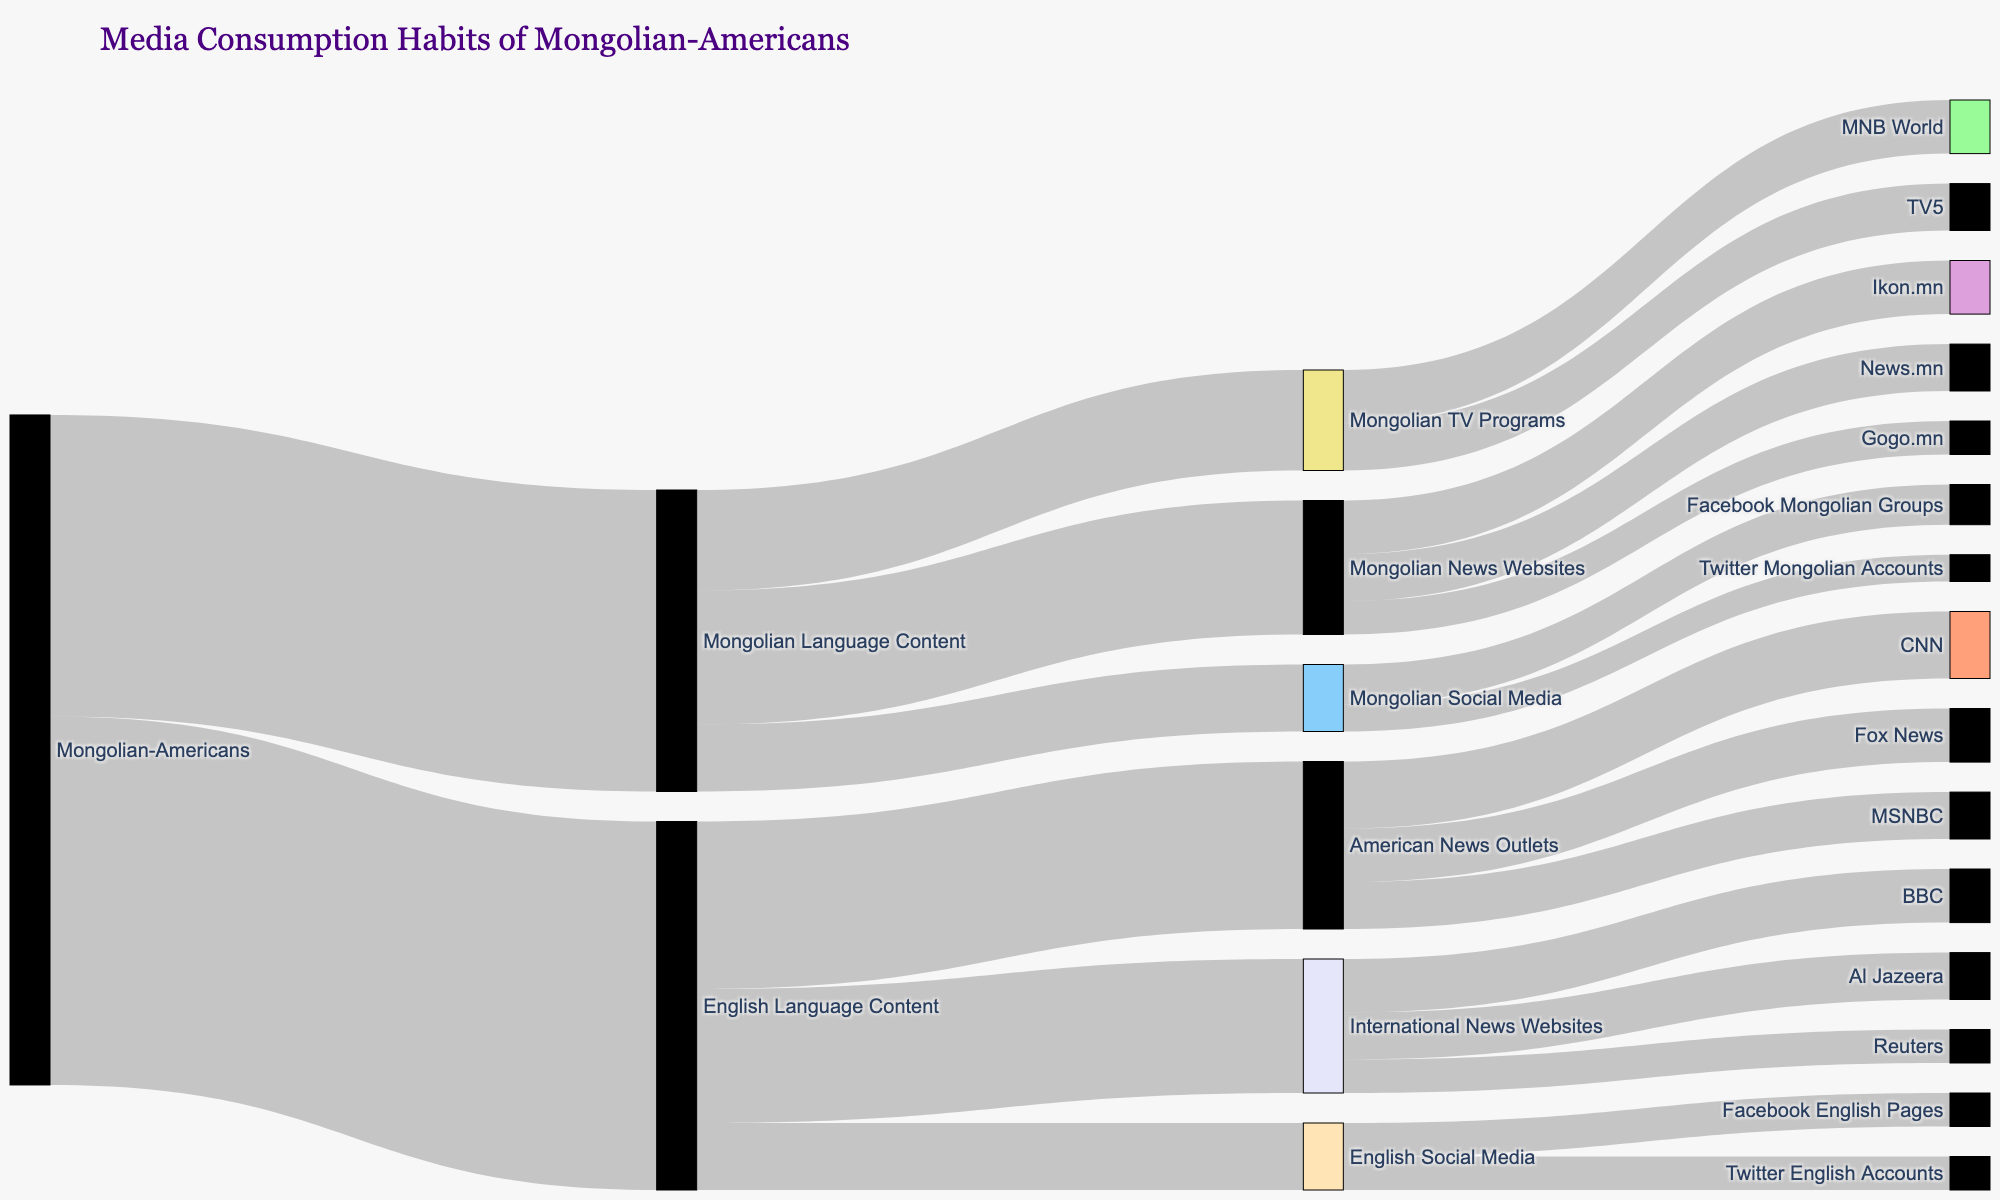What is the title of the figure? The title of the figure is typically displayed at the top of the diagram and gives an overview of what the figure represents. The visual information in the figure states that the title is "Media Consumption Habits of Mongolian-Americans".
Answer: Media Consumption Habits of Mongolian-Americans What is the total percentage of Mongolian-Americans consuming English Language Content? According to the visual representation, the connection between Mongolian-Americans and English Language Content is labeled with a value. Referring to the figure, the value is 55.
Answer: 55 Which content type under English Language Content has the largest consumption? To determine this, look at the link values flowing out from English Language Content. The link with the highest value will indicate the most consumed content type. The largest value is 25, corresponding to American News Outlets.
Answer: American News Outlets How many Mongolian-Americans consume Mongolian TV Programs? First, note the value associated with Mongolian Language Content connecting to Mongolian TV Programs. The figure shows that this value is 15.
Answer: 15 What is the sum of Mongolian-Americans consuming English Social Media and Mongolian Social Media? The values connected from English Language Content to English Social Media and from Mongolian Language Content to Mongolian Social Media are needed. Summing these values (10 for Mongolian Social Media and 10 for English Social Media) gives a total of 20.
Answer: 20 Are there more Mongolian-Americans consuming International News Websites or Mongolian News Websites? Compare the values linked to International News Websites and Mongolian News Websites. International News Websites have a value of 20, while Mongolian News Websites have a value of 20 as well.
Answer: Equal Which specific American news outlet has the highest consumption among Mongolian-Americans? Look at the connections branching out from American News Outlets and find the individual link with the highest value. According to the diagram, CNN has the highest value of 10.
Answer: CNN What percentage of Mongolian News Websites consumption is attributed to Ikon.mn? To solve this, find the value linked to Ikon.mn and divide by the total value for Mongolian News Websites. Ikon.mn has a value of 8, and the total for Mongolian News Websites is 20. Thus, (8/20) * 100 equals 40%.
Answer: 40% How does the consumption of Mongolian Social Media compare to English Social Media? Compare the values flowing from both Mongolian Language Content and English Language Content to their respective social media types. Both Mongolian Social Media and English Social Media have a value of 10.
Answer: Equal Which specific network has the lowest consumption under English Social Media? Examine the figures linked from English Social Media to their corresponding networks. The links show equal values (5 each) for both Facebook English Pages and Twitter English Accounts. Since both have the same value, neither is the lowest.
Answer: Equal 